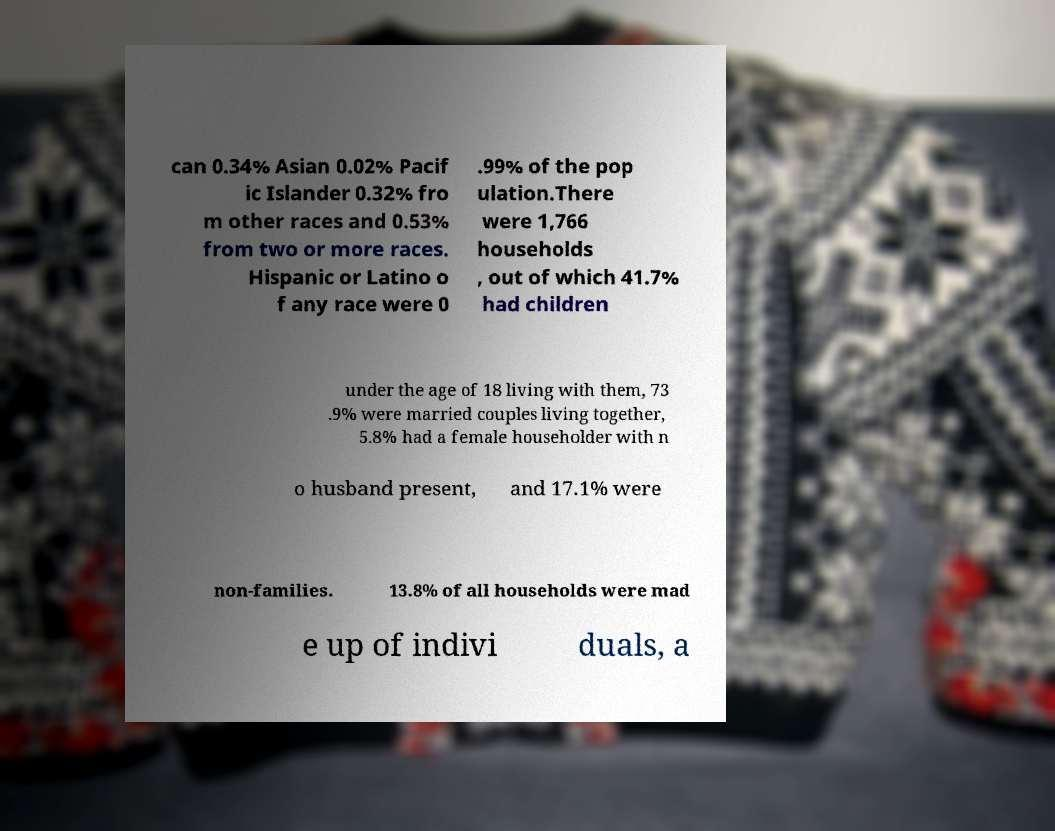Could you extract and type out the text from this image? can 0.34% Asian 0.02% Pacif ic Islander 0.32% fro m other races and 0.53% from two or more races. Hispanic or Latino o f any race were 0 .99% of the pop ulation.There were 1,766 households , out of which 41.7% had children under the age of 18 living with them, 73 .9% were married couples living together, 5.8% had a female householder with n o husband present, and 17.1% were non-families. 13.8% of all households were mad e up of indivi duals, a 